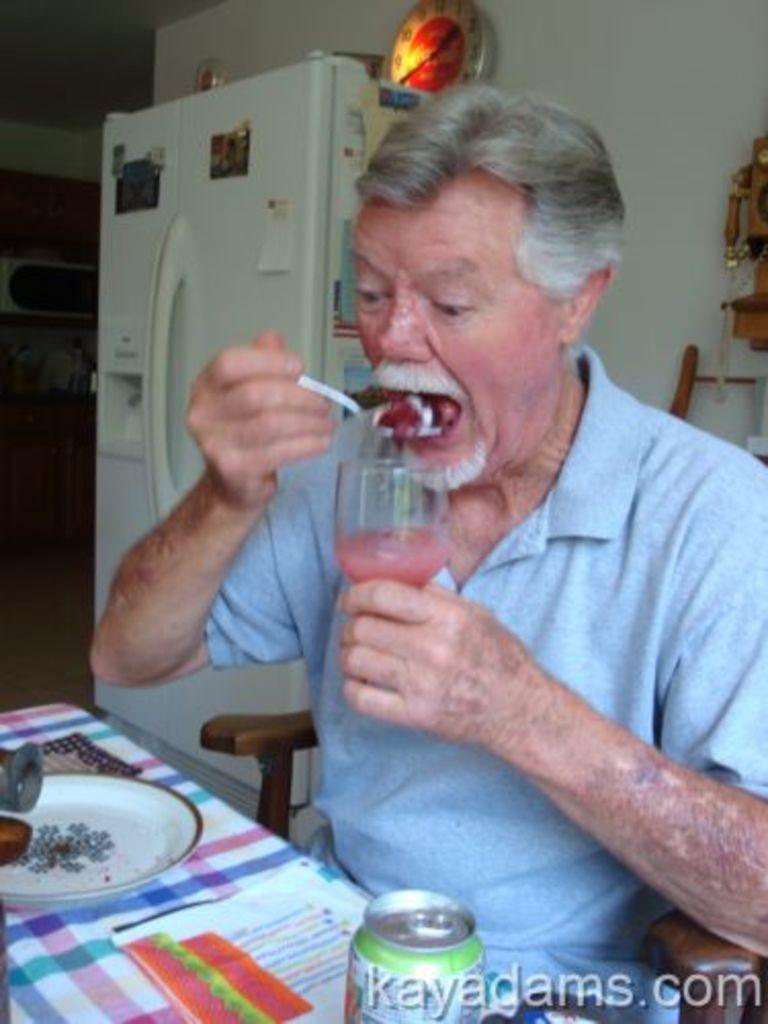How would you summarize this image in a sentence or two? In a picture we can find a man sitting on a chair and having something with a spoon near the table. On the table we can find plate, tin and a paper. In the background we can find a fridge, a wall and a clock. 